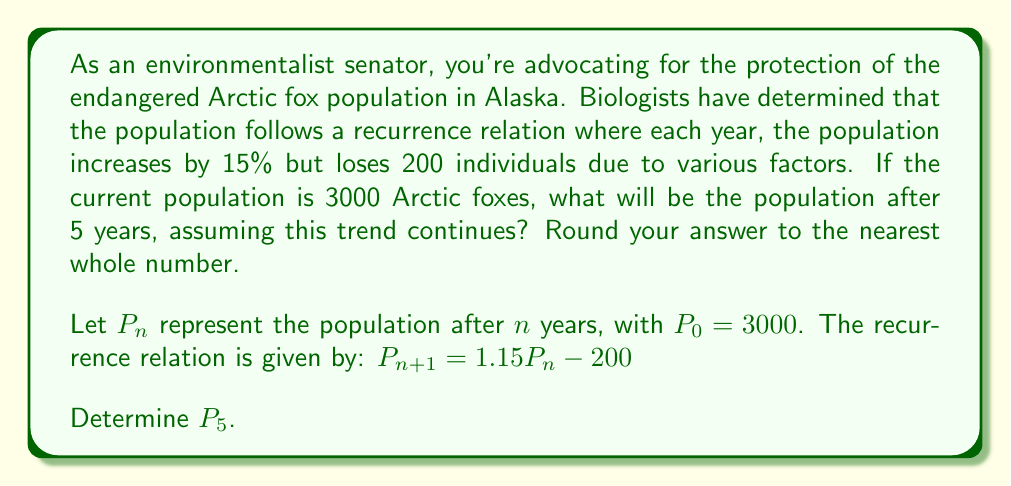Can you solve this math problem? To solve this problem, we need to apply the given recurrence relation iteratively for 5 years:

1) Start with $P_0 = 3000$

2) For year 1:
   $P_1 = 1.15P_0 - 200 = 1.15(3000) - 200 = 3450 - 200 = 3250$

3) For year 2:
   $P_2 = 1.15P_1 - 200 = 1.15(3250) - 200 = 3737.5 - 200 = 3537.5$

4) For year 3:
   $P_3 = 1.15P_2 - 200 = 1.15(3537.5) - 200 = 4068.125 - 200 = 3868.125$

5) For year 4:
   $P_4 = 1.15P_3 - 200 = 1.15(3868.125) - 200 = 4448.34375 - 200 = 4248.34375$

6) For year 5:
   $P_5 = 1.15P_4 - 200 = 1.15(4248.34375) - 200 = 4885.5953125 - 200 = 4685.5953125$

7) Rounding to the nearest whole number:
   $P_5 \approx 4686$

Therefore, after 5 years, the Arctic fox population will be approximately 4686.
Answer: 4686 Arctic foxes 